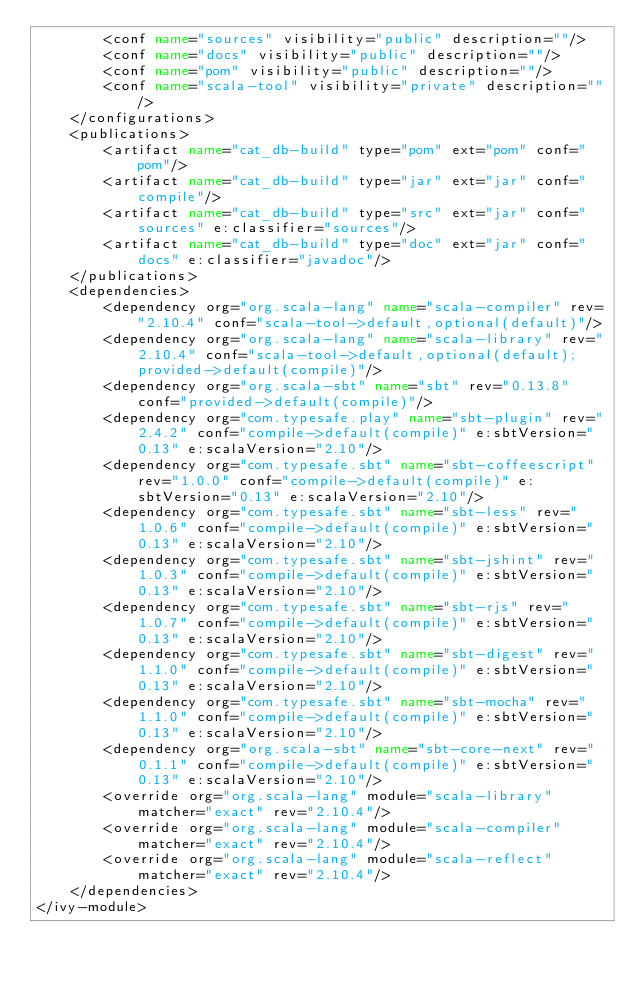Convert code to text. <code><loc_0><loc_0><loc_500><loc_500><_XML_>		<conf name="sources" visibility="public" description=""/>
		<conf name="docs" visibility="public" description=""/>
		<conf name="pom" visibility="public" description=""/>
		<conf name="scala-tool" visibility="private" description=""/>
	</configurations>
	<publications>
		<artifact name="cat_db-build" type="pom" ext="pom" conf="pom"/>
		<artifact name="cat_db-build" type="jar" ext="jar" conf="compile"/>
		<artifact name="cat_db-build" type="src" ext="jar" conf="sources" e:classifier="sources"/>
		<artifact name="cat_db-build" type="doc" ext="jar" conf="docs" e:classifier="javadoc"/>
	</publications>
	<dependencies>
		<dependency org="org.scala-lang" name="scala-compiler" rev="2.10.4" conf="scala-tool->default,optional(default)"/>
		<dependency org="org.scala-lang" name="scala-library" rev="2.10.4" conf="scala-tool->default,optional(default);provided->default(compile)"/>
		<dependency org="org.scala-sbt" name="sbt" rev="0.13.8" conf="provided->default(compile)"/>
		<dependency org="com.typesafe.play" name="sbt-plugin" rev="2.4.2" conf="compile->default(compile)" e:sbtVersion="0.13" e:scalaVersion="2.10"/>
		<dependency org="com.typesafe.sbt" name="sbt-coffeescript" rev="1.0.0" conf="compile->default(compile)" e:sbtVersion="0.13" e:scalaVersion="2.10"/>
		<dependency org="com.typesafe.sbt" name="sbt-less" rev="1.0.6" conf="compile->default(compile)" e:sbtVersion="0.13" e:scalaVersion="2.10"/>
		<dependency org="com.typesafe.sbt" name="sbt-jshint" rev="1.0.3" conf="compile->default(compile)" e:sbtVersion="0.13" e:scalaVersion="2.10"/>
		<dependency org="com.typesafe.sbt" name="sbt-rjs" rev="1.0.7" conf="compile->default(compile)" e:sbtVersion="0.13" e:scalaVersion="2.10"/>
		<dependency org="com.typesafe.sbt" name="sbt-digest" rev="1.1.0" conf="compile->default(compile)" e:sbtVersion="0.13" e:scalaVersion="2.10"/>
		<dependency org="com.typesafe.sbt" name="sbt-mocha" rev="1.1.0" conf="compile->default(compile)" e:sbtVersion="0.13" e:scalaVersion="2.10"/>
		<dependency org="org.scala-sbt" name="sbt-core-next" rev="0.1.1" conf="compile->default(compile)" e:sbtVersion="0.13" e:scalaVersion="2.10"/>
		<override org="org.scala-lang" module="scala-library" matcher="exact" rev="2.10.4"/>
		<override org="org.scala-lang" module="scala-compiler" matcher="exact" rev="2.10.4"/>
		<override org="org.scala-lang" module="scala-reflect" matcher="exact" rev="2.10.4"/>
	</dependencies>
</ivy-module>
</code> 